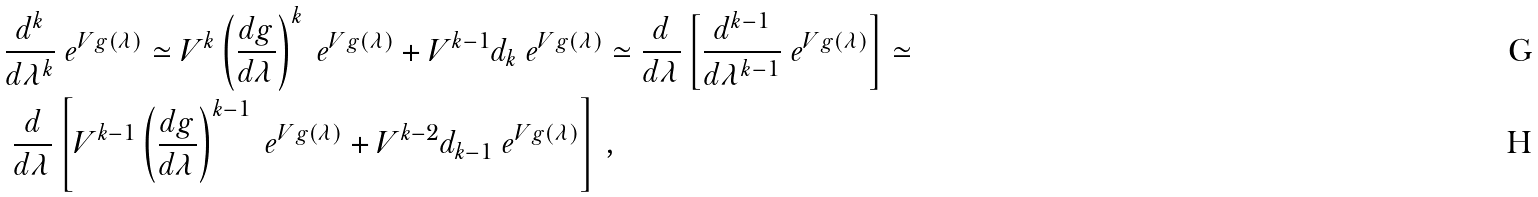<formula> <loc_0><loc_0><loc_500><loc_500>& \frac { d ^ { k } } { d \lambda ^ { k } } \ e ^ { V g ( \lambda ) } \simeq V ^ { k } \left ( \frac { d g } { d \lambda } \right ) ^ { k } \ e ^ { V g ( \lambda ) } + V ^ { k - 1 } d _ { k } \ e ^ { V g ( \lambda ) } \simeq \frac { d } { d \lambda } \left [ \frac { d ^ { k - 1 } } { d \lambda ^ { k - 1 } } \ e ^ { V g ( \lambda ) } \right ] \simeq \\ & \ \frac { d } { d \lambda } \left [ V ^ { k - 1 } \left ( \frac { d g } { d \lambda } \right ) ^ { k - 1 } \ e ^ { V g ( \lambda ) } + V ^ { k - 2 } d _ { k - 1 } \ e ^ { V g ( \lambda ) } \right ] \, ,</formula> 